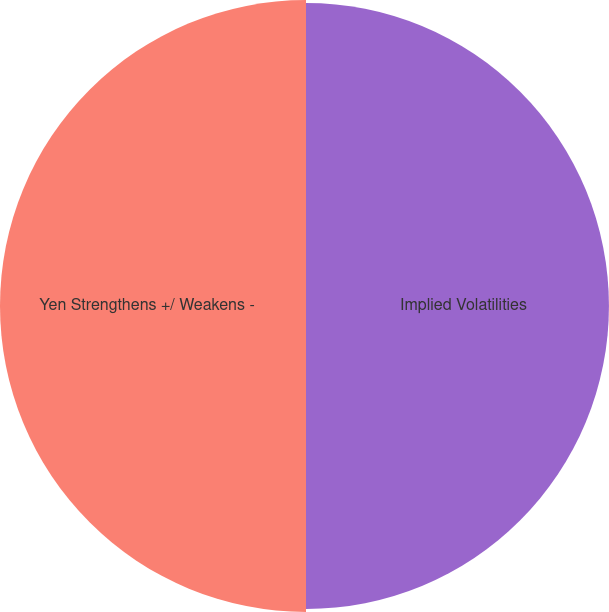Convert chart to OTSL. <chart><loc_0><loc_0><loc_500><loc_500><pie_chart><fcel>Implied Volatilities<fcel>Yen Strengthens +/ Weakens -<nl><fcel>49.75%<fcel>50.25%<nl></chart> 